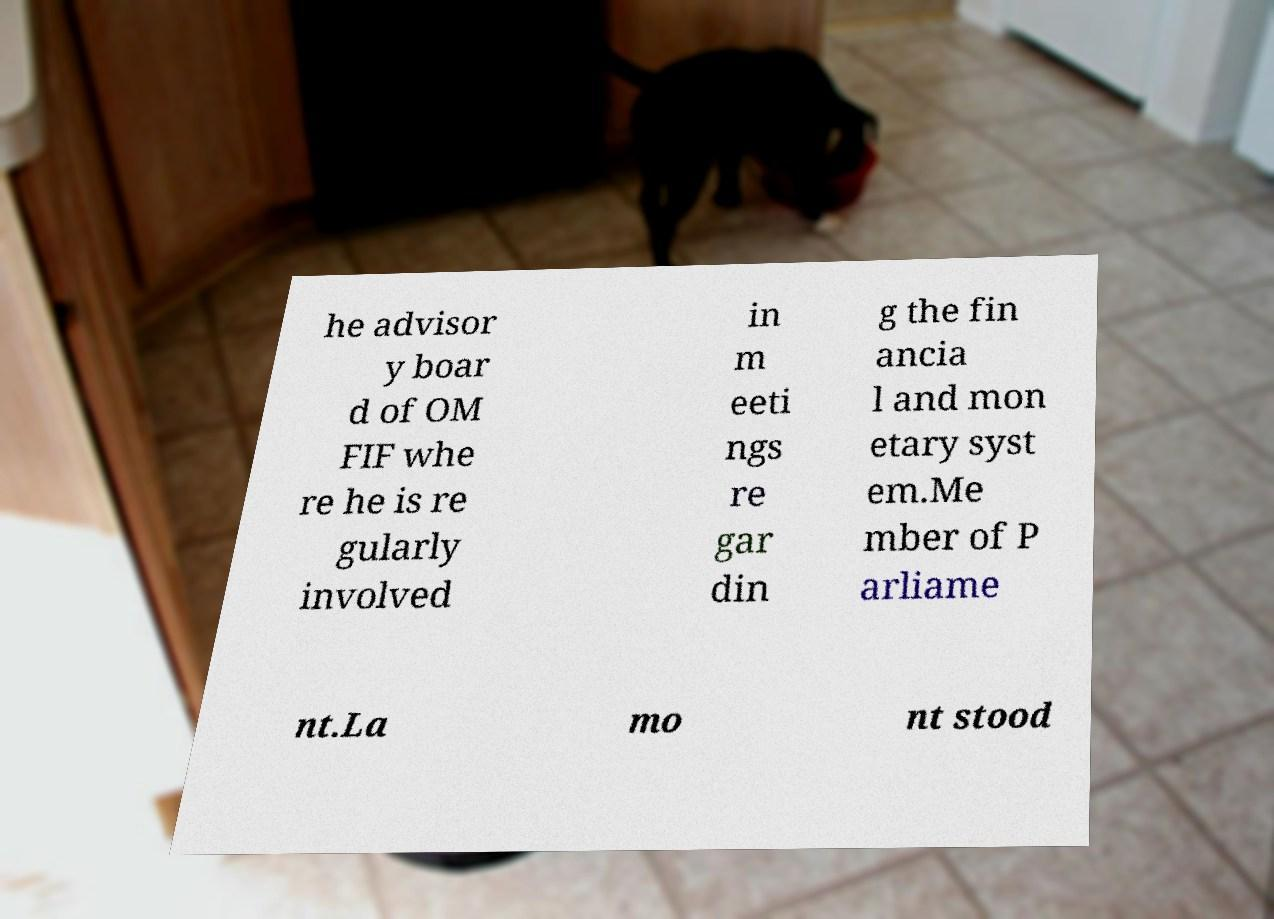For documentation purposes, I need the text within this image transcribed. Could you provide that? he advisor y boar d of OM FIF whe re he is re gularly involved in m eeti ngs re gar din g the fin ancia l and mon etary syst em.Me mber of P arliame nt.La mo nt stood 